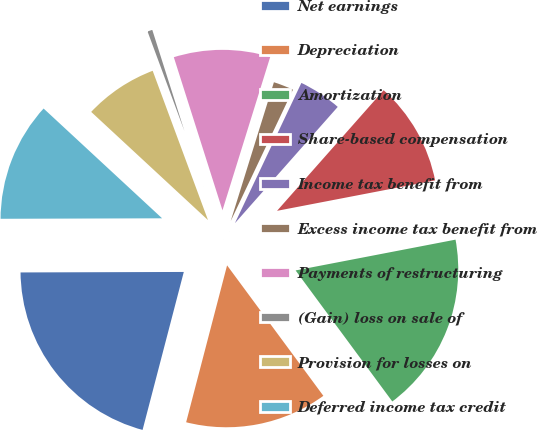Convert chart to OTSL. <chart><loc_0><loc_0><loc_500><loc_500><pie_chart><fcel>Net earnings<fcel>Depreciation<fcel>Amortization<fcel>Share-based compensation<fcel>Income tax benefit from<fcel>Excess income tax benefit from<fcel>Payments of restructuring<fcel>(Gain) loss on sale of<fcel>Provision for losses on<fcel>Deferred income tax credit<nl><fcel>20.89%<fcel>14.18%<fcel>17.91%<fcel>10.45%<fcel>4.48%<fcel>2.24%<fcel>9.7%<fcel>0.75%<fcel>7.46%<fcel>11.94%<nl></chart> 